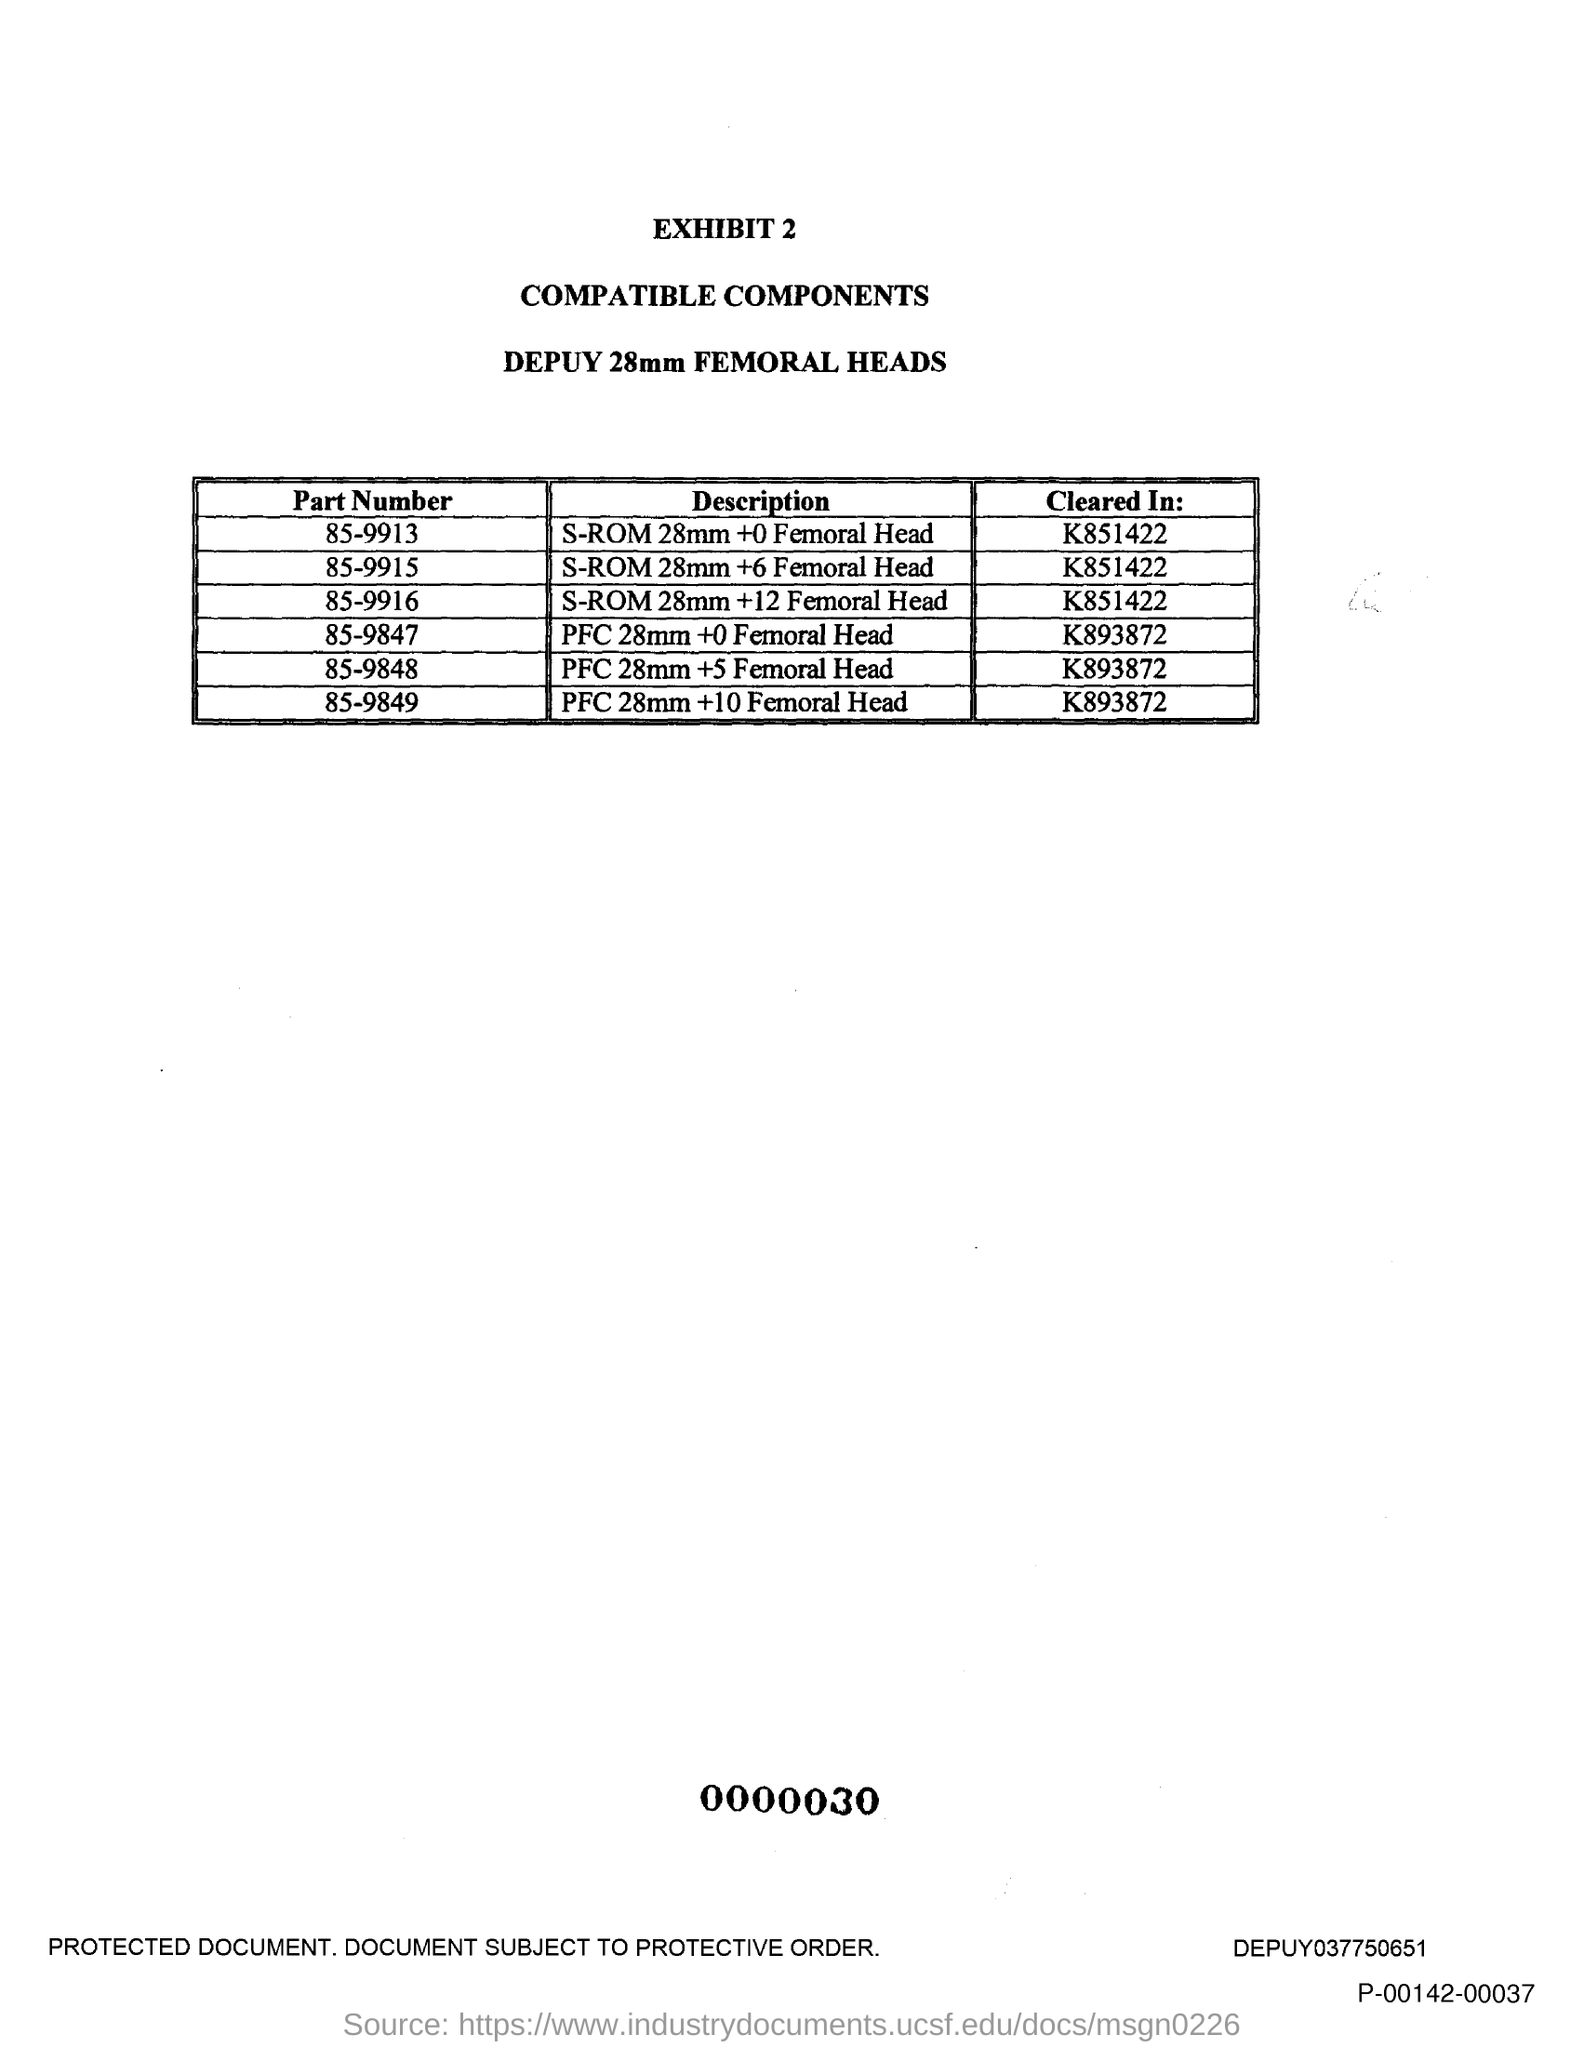Draw attention to some important aspects in this diagram. The second title in this document is "Compatible Components. 